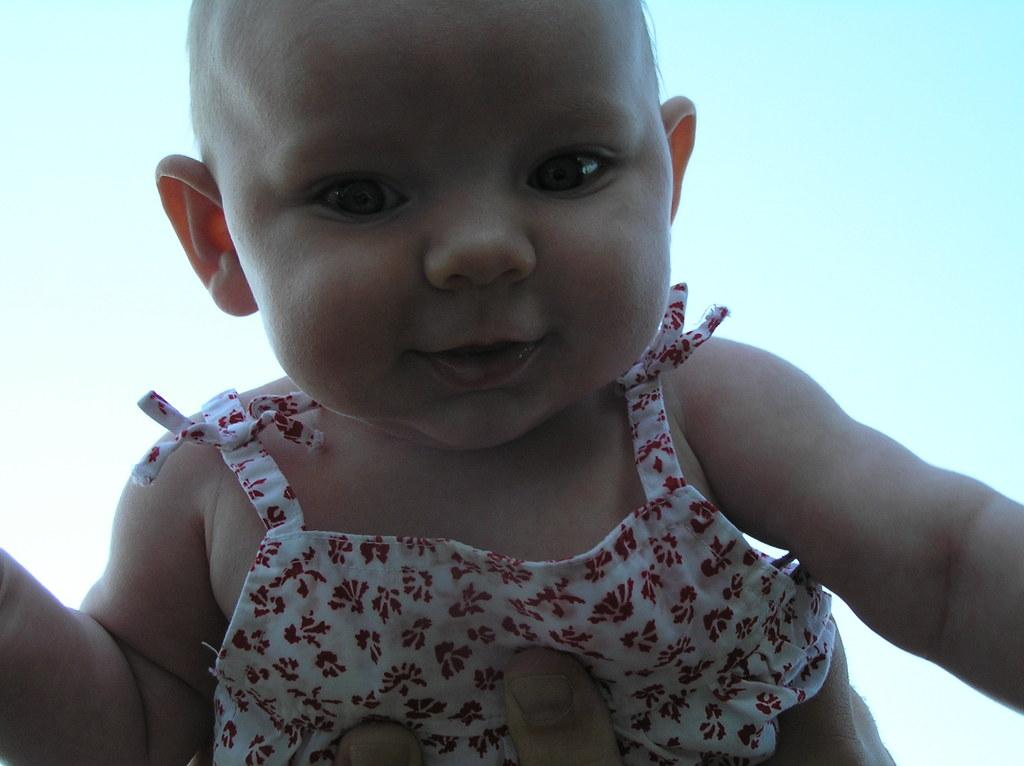What is the main subject of the image? There is a baby in the image. What is the baby doing in the image? The baby is smiling. Whose fingers are visible at the bottom of the image? Human fingers are visible at the bottom of the image. What can be seen in the background of the image? There is a sky in the background of the image. How many ducks are visible in the image? There are no ducks present in the image. What type of truck can be seen in the background of the image? There is no truck present in the image. 